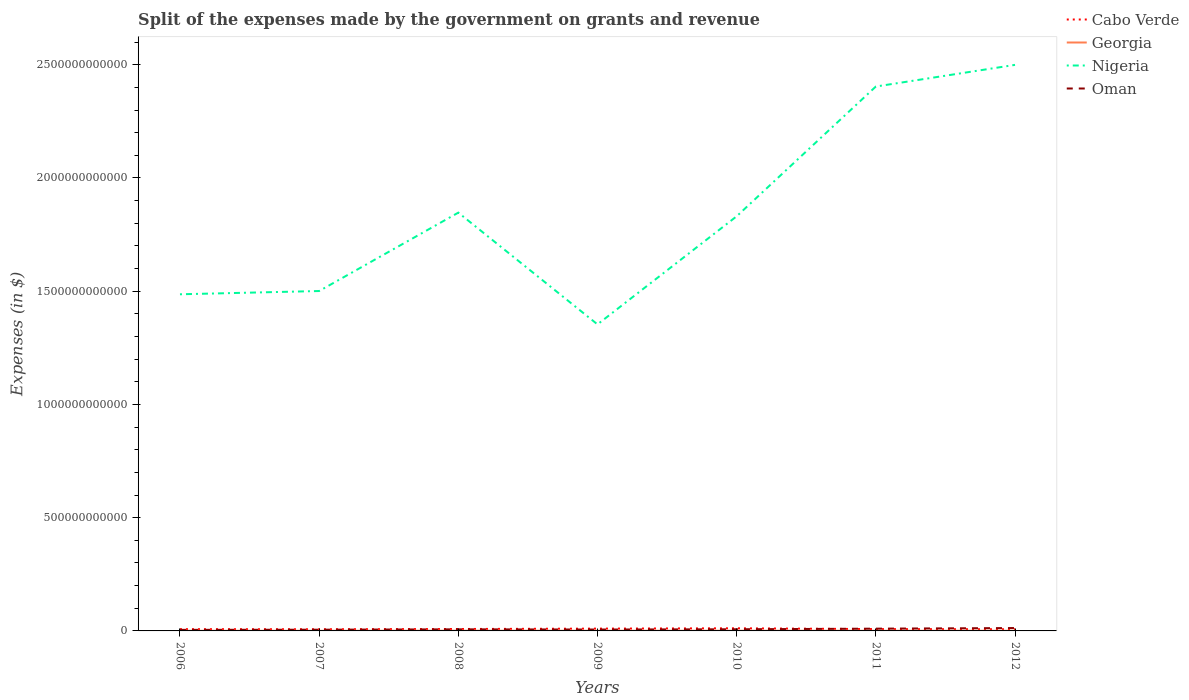Does the line corresponding to Cabo Verde intersect with the line corresponding to Oman?
Provide a short and direct response. Yes. Across all years, what is the maximum expenses made by the government on grants and revenue in Nigeria?
Your answer should be compact. 1.35e+12. In which year was the expenses made by the government on grants and revenue in Georgia maximum?
Your answer should be very brief. 2007. What is the total expenses made by the government on grants and revenue in Georgia in the graph?
Provide a succinct answer. -1.69e+08. What is the difference between the highest and the second highest expenses made by the government on grants and revenue in Nigeria?
Make the answer very short. 1.15e+12. Is the expenses made by the government on grants and revenue in Georgia strictly greater than the expenses made by the government on grants and revenue in Cabo Verde over the years?
Give a very brief answer. Yes. How many lines are there?
Provide a short and direct response. 4. What is the difference between two consecutive major ticks on the Y-axis?
Offer a very short reply. 5.00e+11. Does the graph contain any zero values?
Your answer should be very brief. No. How many legend labels are there?
Provide a short and direct response. 4. How are the legend labels stacked?
Ensure brevity in your answer.  Vertical. What is the title of the graph?
Your answer should be compact. Split of the expenses made by the government on grants and revenue. Does "Senegal" appear as one of the legend labels in the graph?
Your answer should be very brief. No. What is the label or title of the Y-axis?
Offer a terse response. Expenses (in $). What is the Expenses (in $) in Cabo Verde in 2006?
Provide a short and direct response. 7.76e+09. What is the Expenses (in $) in Georgia in 2006?
Make the answer very short. 6.60e+08. What is the Expenses (in $) in Nigeria in 2006?
Keep it short and to the point. 1.49e+12. What is the Expenses (in $) of Oman in 2006?
Your answer should be very brief. 4.63e+09. What is the Expenses (in $) in Cabo Verde in 2007?
Your answer should be very brief. 7.32e+09. What is the Expenses (in $) of Georgia in 2007?
Give a very brief answer. 5.61e+08. What is the Expenses (in $) in Nigeria in 2007?
Your response must be concise. 1.50e+12. What is the Expenses (in $) in Oman in 2007?
Give a very brief answer. 5.40e+09. What is the Expenses (in $) in Cabo Verde in 2008?
Your response must be concise. 8.47e+09. What is the Expenses (in $) in Georgia in 2008?
Ensure brevity in your answer.  9.76e+08. What is the Expenses (in $) of Nigeria in 2008?
Offer a terse response. 1.85e+12. What is the Expenses (in $) in Oman in 2008?
Give a very brief answer. 7.02e+09. What is the Expenses (in $) of Cabo Verde in 2009?
Keep it short and to the point. 1.02e+1. What is the Expenses (in $) of Georgia in 2009?
Give a very brief answer. 7.55e+08. What is the Expenses (in $) in Nigeria in 2009?
Your answer should be very brief. 1.35e+12. What is the Expenses (in $) in Oman in 2009?
Ensure brevity in your answer.  6.14e+09. What is the Expenses (in $) of Cabo Verde in 2010?
Make the answer very short. 1.16e+1. What is the Expenses (in $) of Georgia in 2010?
Your answer should be compact. 8.29e+08. What is the Expenses (in $) in Nigeria in 2010?
Keep it short and to the point. 1.83e+12. What is the Expenses (in $) of Oman in 2010?
Your answer should be compact. 7.31e+09. What is the Expenses (in $) in Cabo Verde in 2011?
Offer a terse response. 8.08e+09. What is the Expenses (in $) in Georgia in 2011?
Offer a terse response. 5.87e+08. What is the Expenses (in $) of Nigeria in 2011?
Your answer should be compact. 2.40e+12. What is the Expenses (in $) in Oman in 2011?
Your answer should be very brief. 9.99e+09. What is the Expenses (in $) in Cabo Verde in 2012?
Keep it short and to the point. 7.30e+09. What is the Expenses (in $) of Georgia in 2012?
Keep it short and to the point. 7.47e+08. What is the Expenses (in $) of Nigeria in 2012?
Offer a terse response. 2.50e+12. What is the Expenses (in $) in Oman in 2012?
Your answer should be compact. 1.27e+1. Across all years, what is the maximum Expenses (in $) of Cabo Verde?
Keep it short and to the point. 1.16e+1. Across all years, what is the maximum Expenses (in $) in Georgia?
Provide a succinct answer. 9.76e+08. Across all years, what is the maximum Expenses (in $) of Nigeria?
Offer a very short reply. 2.50e+12. Across all years, what is the maximum Expenses (in $) in Oman?
Give a very brief answer. 1.27e+1. Across all years, what is the minimum Expenses (in $) in Cabo Verde?
Keep it short and to the point. 7.30e+09. Across all years, what is the minimum Expenses (in $) in Georgia?
Your answer should be compact. 5.61e+08. Across all years, what is the minimum Expenses (in $) in Nigeria?
Provide a succinct answer. 1.35e+12. Across all years, what is the minimum Expenses (in $) of Oman?
Your answer should be compact. 4.63e+09. What is the total Expenses (in $) in Cabo Verde in the graph?
Give a very brief answer. 6.07e+1. What is the total Expenses (in $) in Georgia in the graph?
Provide a short and direct response. 5.12e+09. What is the total Expenses (in $) in Nigeria in the graph?
Give a very brief answer. 1.29e+13. What is the total Expenses (in $) in Oman in the graph?
Offer a terse response. 5.32e+1. What is the difference between the Expenses (in $) of Cabo Verde in 2006 and that in 2007?
Your response must be concise. 4.42e+08. What is the difference between the Expenses (in $) of Georgia in 2006 and that in 2007?
Your answer should be very brief. 9.92e+07. What is the difference between the Expenses (in $) in Nigeria in 2006 and that in 2007?
Give a very brief answer. -1.44e+1. What is the difference between the Expenses (in $) of Oman in 2006 and that in 2007?
Your answer should be compact. -7.66e+08. What is the difference between the Expenses (in $) of Cabo Verde in 2006 and that in 2008?
Make the answer very short. -7.10e+08. What is the difference between the Expenses (in $) of Georgia in 2006 and that in 2008?
Your response must be concise. -3.16e+08. What is the difference between the Expenses (in $) of Nigeria in 2006 and that in 2008?
Your answer should be compact. -3.60e+11. What is the difference between the Expenses (in $) in Oman in 2006 and that in 2008?
Provide a short and direct response. -2.38e+09. What is the difference between the Expenses (in $) of Cabo Verde in 2006 and that in 2009?
Offer a very short reply. -2.39e+09. What is the difference between the Expenses (in $) in Georgia in 2006 and that in 2009?
Offer a very short reply. -9.51e+07. What is the difference between the Expenses (in $) of Nigeria in 2006 and that in 2009?
Make the answer very short. 1.33e+11. What is the difference between the Expenses (in $) of Oman in 2006 and that in 2009?
Your answer should be very brief. -1.50e+09. What is the difference between the Expenses (in $) of Cabo Verde in 2006 and that in 2010?
Make the answer very short. -3.85e+09. What is the difference between the Expenses (in $) of Georgia in 2006 and that in 2010?
Keep it short and to the point. -1.69e+08. What is the difference between the Expenses (in $) in Nigeria in 2006 and that in 2010?
Offer a terse response. -3.44e+11. What is the difference between the Expenses (in $) of Oman in 2006 and that in 2010?
Your answer should be very brief. -2.67e+09. What is the difference between the Expenses (in $) of Cabo Verde in 2006 and that in 2011?
Keep it short and to the point. -3.14e+08. What is the difference between the Expenses (in $) of Georgia in 2006 and that in 2011?
Ensure brevity in your answer.  7.34e+07. What is the difference between the Expenses (in $) of Nigeria in 2006 and that in 2011?
Make the answer very short. -9.17e+11. What is the difference between the Expenses (in $) of Oman in 2006 and that in 2011?
Your answer should be very brief. -5.35e+09. What is the difference between the Expenses (in $) of Cabo Verde in 2006 and that in 2012?
Offer a terse response. 4.65e+08. What is the difference between the Expenses (in $) of Georgia in 2006 and that in 2012?
Ensure brevity in your answer.  -8.69e+07. What is the difference between the Expenses (in $) in Nigeria in 2006 and that in 2012?
Your response must be concise. -1.01e+12. What is the difference between the Expenses (in $) of Oman in 2006 and that in 2012?
Keep it short and to the point. -8.05e+09. What is the difference between the Expenses (in $) of Cabo Verde in 2007 and that in 2008?
Give a very brief answer. -1.15e+09. What is the difference between the Expenses (in $) in Georgia in 2007 and that in 2008?
Provide a succinct answer. -4.15e+08. What is the difference between the Expenses (in $) of Nigeria in 2007 and that in 2008?
Ensure brevity in your answer.  -3.46e+11. What is the difference between the Expenses (in $) of Oman in 2007 and that in 2008?
Offer a terse response. -1.62e+09. What is the difference between the Expenses (in $) in Cabo Verde in 2007 and that in 2009?
Keep it short and to the point. -2.83e+09. What is the difference between the Expenses (in $) in Georgia in 2007 and that in 2009?
Your answer should be very brief. -1.94e+08. What is the difference between the Expenses (in $) in Nigeria in 2007 and that in 2009?
Offer a very short reply. 1.47e+11. What is the difference between the Expenses (in $) of Oman in 2007 and that in 2009?
Your response must be concise. -7.37e+08. What is the difference between the Expenses (in $) in Cabo Verde in 2007 and that in 2010?
Offer a very short reply. -4.29e+09. What is the difference between the Expenses (in $) in Georgia in 2007 and that in 2010?
Your answer should be compact. -2.68e+08. What is the difference between the Expenses (in $) of Nigeria in 2007 and that in 2010?
Offer a terse response. -3.30e+11. What is the difference between the Expenses (in $) of Oman in 2007 and that in 2010?
Keep it short and to the point. -1.90e+09. What is the difference between the Expenses (in $) in Cabo Verde in 2007 and that in 2011?
Make the answer very short. -7.56e+08. What is the difference between the Expenses (in $) of Georgia in 2007 and that in 2011?
Your answer should be compact. -2.58e+07. What is the difference between the Expenses (in $) of Nigeria in 2007 and that in 2011?
Keep it short and to the point. -9.03e+11. What is the difference between the Expenses (in $) in Oman in 2007 and that in 2011?
Your response must be concise. -4.59e+09. What is the difference between the Expenses (in $) in Cabo Verde in 2007 and that in 2012?
Offer a terse response. 2.32e+07. What is the difference between the Expenses (in $) in Georgia in 2007 and that in 2012?
Your response must be concise. -1.86e+08. What is the difference between the Expenses (in $) in Nigeria in 2007 and that in 2012?
Provide a succinct answer. -9.99e+11. What is the difference between the Expenses (in $) of Oman in 2007 and that in 2012?
Ensure brevity in your answer.  -7.29e+09. What is the difference between the Expenses (in $) of Cabo Verde in 2008 and that in 2009?
Give a very brief answer. -1.68e+09. What is the difference between the Expenses (in $) of Georgia in 2008 and that in 2009?
Offer a terse response. 2.21e+08. What is the difference between the Expenses (in $) of Nigeria in 2008 and that in 2009?
Your response must be concise. 4.93e+11. What is the difference between the Expenses (in $) of Oman in 2008 and that in 2009?
Offer a terse response. 8.79e+08. What is the difference between the Expenses (in $) of Cabo Verde in 2008 and that in 2010?
Keep it short and to the point. -3.14e+09. What is the difference between the Expenses (in $) of Georgia in 2008 and that in 2010?
Ensure brevity in your answer.  1.47e+08. What is the difference between the Expenses (in $) of Nigeria in 2008 and that in 2010?
Provide a succinct answer. 1.61e+1. What is the difference between the Expenses (in $) in Oman in 2008 and that in 2010?
Give a very brief answer. -2.88e+08. What is the difference between the Expenses (in $) in Cabo Verde in 2008 and that in 2011?
Your answer should be very brief. 3.96e+08. What is the difference between the Expenses (in $) of Georgia in 2008 and that in 2011?
Offer a very short reply. 3.89e+08. What is the difference between the Expenses (in $) of Nigeria in 2008 and that in 2011?
Your answer should be very brief. -5.57e+11. What is the difference between the Expenses (in $) of Oman in 2008 and that in 2011?
Ensure brevity in your answer.  -2.97e+09. What is the difference between the Expenses (in $) in Cabo Verde in 2008 and that in 2012?
Your answer should be compact. 1.17e+09. What is the difference between the Expenses (in $) of Georgia in 2008 and that in 2012?
Give a very brief answer. 2.29e+08. What is the difference between the Expenses (in $) in Nigeria in 2008 and that in 2012?
Your answer should be very brief. -6.52e+11. What is the difference between the Expenses (in $) in Oman in 2008 and that in 2012?
Offer a very short reply. -5.67e+09. What is the difference between the Expenses (in $) in Cabo Verde in 2009 and that in 2010?
Offer a terse response. -1.45e+09. What is the difference between the Expenses (in $) of Georgia in 2009 and that in 2010?
Keep it short and to the point. -7.38e+07. What is the difference between the Expenses (in $) in Nigeria in 2009 and that in 2010?
Provide a succinct answer. -4.77e+11. What is the difference between the Expenses (in $) in Oman in 2009 and that in 2010?
Offer a very short reply. -1.17e+09. What is the difference between the Expenses (in $) in Cabo Verde in 2009 and that in 2011?
Give a very brief answer. 2.08e+09. What is the difference between the Expenses (in $) of Georgia in 2009 and that in 2011?
Provide a short and direct response. 1.68e+08. What is the difference between the Expenses (in $) of Nigeria in 2009 and that in 2011?
Provide a short and direct response. -1.05e+12. What is the difference between the Expenses (in $) in Oman in 2009 and that in 2011?
Give a very brief answer. -3.85e+09. What is the difference between the Expenses (in $) in Cabo Verde in 2009 and that in 2012?
Keep it short and to the point. 2.86e+09. What is the difference between the Expenses (in $) in Georgia in 2009 and that in 2012?
Offer a very short reply. 8.20e+06. What is the difference between the Expenses (in $) in Nigeria in 2009 and that in 2012?
Provide a succinct answer. -1.15e+12. What is the difference between the Expenses (in $) of Oman in 2009 and that in 2012?
Give a very brief answer. -6.55e+09. What is the difference between the Expenses (in $) in Cabo Verde in 2010 and that in 2011?
Keep it short and to the point. 3.53e+09. What is the difference between the Expenses (in $) of Georgia in 2010 and that in 2011?
Your response must be concise. 2.42e+08. What is the difference between the Expenses (in $) of Nigeria in 2010 and that in 2011?
Your answer should be very brief. -5.73e+11. What is the difference between the Expenses (in $) of Oman in 2010 and that in 2011?
Keep it short and to the point. -2.68e+09. What is the difference between the Expenses (in $) in Cabo Verde in 2010 and that in 2012?
Offer a very short reply. 4.31e+09. What is the difference between the Expenses (in $) in Georgia in 2010 and that in 2012?
Make the answer very short. 8.20e+07. What is the difference between the Expenses (in $) in Nigeria in 2010 and that in 2012?
Offer a terse response. -6.69e+11. What is the difference between the Expenses (in $) in Oman in 2010 and that in 2012?
Your response must be concise. -5.38e+09. What is the difference between the Expenses (in $) of Cabo Verde in 2011 and that in 2012?
Keep it short and to the point. 7.79e+08. What is the difference between the Expenses (in $) in Georgia in 2011 and that in 2012?
Your response must be concise. -1.60e+08. What is the difference between the Expenses (in $) in Nigeria in 2011 and that in 2012?
Your answer should be compact. -9.56e+1. What is the difference between the Expenses (in $) of Oman in 2011 and that in 2012?
Give a very brief answer. -2.70e+09. What is the difference between the Expenses (in $) of Cabo Verde in 2006 and the Expenses (in $) of Georgia in 2007?
Offer a terse response. 7.20e+09. What is the difference between the Expenses (in $) of Cabo Verde in 2006 and the Expenses (in $) of Nigeria in 2007?
Your response must be concise. -1.49e+12. What is the difference between the Expenses (in $) of Cabo Verde in 2006 and the Expenses (in $) of Oman in 2007?
Provide a short and direct response. 2.36e+09. What is the difference between the Expenses (in $) of Georgia in 2006 and the Expenses (in $) of Nigeria in 2007?
Your response must be concise. -1.50e+12. What is the difference between the Expenses (in $) of Georgia in 2006 and the Expenses (in $) of Oman in 2007?
Your answer should be compact. -4.74e+09. What is the difference between the Expenses (in $) in Nigeria in 2006 and the Expenses (in $) in Oman in 2007?
Keep it short and to the point. 1.48e+12. What is the difference between the Expenses (in $) of Cabo Verde in 2006 and the Expenses (in $) of Georgia in 2008?
Give a very brief answer. 6.79e+09. What is the difference between the Expenses (in $) of Cabo Verde in 2006 and the Expenses (in $) of Nigeria in 2008?
Provide a succinct answer. -1.84e+12. What is the difference between the Expenses (in $) of Cabo Verde in 2006 and the Expenses (in $) of Oman in 2008?
Your answer should be compact. 7.44e+08. What is the difference between the Expenses (in $) in Georgia in 2006 and the Expenses (in $) in Nigeria in 2008?
Your answer should be very brief. -1.85e+12. What is the difference between the Expenses (in $) in Georgia in 2006 and the Expenses (in $) in Oman in 2008?
Your answer should be compact. -6.36e+09. What is the difference between the Expenses (in $) in Nigeria in 2006 and the Expenses (in $) in Oman in 2008?
Offer a terse response. 1.48e+12. What is the difference between the Expenses (in $) of Cabo Verde in 2006 and the Expenses (in $) of Georgia in 2009?
Your response must be concise. 7.01e+09. What is the difference between the Expenses (in $) in Cabo Verde in 2006 and the Expenses (in $) in Nigeria in 2009?
Provide a succinct answer. -1.35e+12. What is the difference between the Expenses (in $) in Cabo Verde in 2006 and the Expenses (in $) in Oman in 2009?
Provide a short and direct response. 1.62e+09. What is the difference between the Expenses (in $) in Georgia in 2006 and the Expenses (in $) in Nigeria in 2009?
Provide a short and direct response. -1.35e+12. What is the difference between the Expenses (in $) of Georgia in 2006 and the Expenses (in $) of Oman in 2009?
Make the answer very short. -5.48e+09. What is the difference between the Expenses (in $) in Nigeria in 2006 and the Expenses (in $) in Oman in 2009?
Your response must be concise. 1.48e+12. What is the difference between the Expenses (in $) of Cabo Verde in 2006 and the Expenses (in $) of Georgia in 2010?
Provide a short and direct response. 6.93e+09. What is the difference between the Expenses (in $) of Cabo Verde in 2006 and the Expenses (in $) of Nigeria in 2010?
Your answer should be very brief. -1.82e+12. What is the difference between the Expenses (in $) of Cabo Verde in 2006 and the Expenses (in $) of Oman in 2010?
Give a very brief answer. 4.57e+08. What is the difference between the Expenses (in $) of Georgia in 2006 and the Expenses (in $) of Nigeria in 2010?
Provide a short and direct response. -1.83e+12. What is the difference between the Expenses (in $) in Georgia in 2006 and the Expenses (in $) in Oman in 2010?
Offer a terse response. -6.64e+09. What is the difference between the Expenses (in $) of Nigeria in 2006 and the Expenses (in $) of Oman in 2010?
Give a very brief answer. 1.48e+12. What is the difference between the Expenses (in $) of Cabo Verde in 2006 and the Expenses (in $) of Georgia in 2011?
Keep it short and to the point. 7.18e+09. What is the difference between the Expenses (in $) of Cabo Verde in 2006 and the Expenses (in $) of Nigeria in 2011?
Provide a succinct answer. -2.40e+12. What is the difference between the Expenses (in $) of Cabo Verde in 2006 and the Expenses (in $) of Oman in 2011?
Your response must be concise. -2.23e+09. What is the difference between the Expenses (in $) of Georgia in 2006 and the Expenses (in $) of Nigeria in 2011?
Keep it short and to the point. -2.40e+12. What is the difference between the Expenses (in $) of Georgia in 2006 and the Expenses (in $) of Oman in 2011?
Provide a short and direct response. -9.33e+09. What is the difference between the Expenses (in $) in Nigeria in 2006 and the Expenses (in $) in Oman in 2011?
Give a very brief answer. 1.48e+12. What is the difference between the Expenses (in $) of Cabo Verde in 2006 and the Expenses (in $) of Georgia in 2012?
Your answer should be very brief. 7.02e+09. What is the difference between the Expenses (in $) of Cabo Verde in 2006 and the Expenses (in $) of Nigeria in 2012?
Offer a very short reply. -2.49e+12. What is the difference between the Expenses (in $) of Cabo Verde in 2006 and the Expenses (in $) of Oman in 2012?
Provide a succinct answer. -4.93e+09. What is the difference between the Expenses (in $) in Georgia in 2006 and the Expenses (in $) in Nigeria in 2012?
Make the answer very short. -2.50e+12. What is the difference between the Expenses (in $) of Georgia in 2006 and the Expenses (in $) of Oman in 2012?
Keep it short and to the point. -1.20e+1. What is the difference between the Expenses (in $) in Nigeria in 2006 and the Expenses (in $) in Oman in 2012?
Your answer should be very brief. 1.47e+12. What is the difference between the Expenses (in $) in Cabo Verde in 2007 and the Expenses (in $) in Georgia in 2008?
Make the answer very short. 6.34e+09. What is the difference between the Expenses (in $) of Cabo Verde in 2007 and the Expenses (in $) of Nigeria in 2008?
Your response must be concise. -1.84e+12. What is the difference between the Expenses (in $) in Cabo Verde in 2007 and the Expenses (in $) in Oman in 2008?
Keep it short and to the point. 3.03e+08. What is the difference between the Expenses (in $) in Georgia in 2007 and the Expenses (in $) in Nigeria in 2008?
Offer a very short reply. -1.85e+12. What is the difference between the Expenses (in $) in Georgia in 2007 and the Expenses (in $) in Oman in 2008?
Offer a very short reply. -6.46e+09. What is the difference between the Expenses (in $) in Nigeria in 2007 and the Expenses (in $) in Oman in 2008?
Your response must be concise. 1.49e+12. What is the difference between the Expenses (in $) in Cabo Verde in 2007 and the Expenses (in $) in Georgia in 2009?
Give a very brief answer. 6.57e+09. What is the difference between the Expenses (in $) of Cabo Verde in 2007 and the Expenses (in $) of Nigeria in 2009?
Ensure brevity in your answer.  -1.35e+12. What is the difference between the Expenses (in $) in Cabo Verde in 2007 and the Expenses (in $) in Oman in 2009?
Ensure brevity in your answer.  1.18e+09. What is the difference between the Expenses (in $) in Georgia in 2007 and the Expenses (in $) in Nigeria in 2009?
Make the answer very short. -1.35e+12. What is the difference between the Expenses (in $) of Georgia in 2007 and the Expenses (in $) of Oman in 2009?
Your answer should be very brief. -5.58e+09. What is the difference between the Expenses (in $) in Nigeria in 2007 and the Expenses (in $) in Oman in 2009?
Your response must be concise. 1.49e+12. What is the difference between the Expenses (in $) of Cabo Verde in 2007 and the Expenses (in $) of Georgia in 2010?
Your answer should be very brief. 6.49e+09. What is the difference between the Expenses (in $) in Cabo Verde in 2007 and the Expenses (in $) in Nigeria in 2010?
Offer a very short reply. -1.82e+12. What is the difference between the Expenses (in $) of Cabo Verde in 2007 and the Expenses (in $) of Oman in 2010?
Your response must be concise. 1.51e+07. What is the difference between the Expenses (in $) in Georgia in 2007 and the Expenses (in $) in Nigeria in 2010?
Offer a terse response. -1.83e+12. What is the difference between the Expenses (in $) in Georgia in 2007 and the Expenses (in $) in Oman in 2010?
Your answer should be compact. -6.74e+09. What is the difference between the Expenses (in $) of Nigeria in 2007 and the Expenses (in $) of Oman in 2010?
Your response must be concise. 1.49e+12. What is the difference between the Expenses (in $) of Cabo Verde in 2007 and the Expenses (in $) of Georgia in 2011?
Keep it short and to the point. 6.73e+09. What is the difference between the Expenses (in $) in Cabo Verde in 2007 and the Expenses (in $) in Nigeria in 2011?
Provide a short and direct response. -2.40e+12. What is the difference between the Expenses (in $) in Cabo Verde in 2007 and the Expenses (in $) in Oman in 2011?
Keep it short and to the point. -2.67e+09. What is the difference between the Expenses (in $) in Georgia in 2007 and the Expenses (in $) in Nigeria in 2011?
Your answer should be very brief. -2.40e+12. What is the difference between the Expenses (in $) in Georgia in 2007 and the Expenses (in $) in Oman in 2011?
Offer a very short reply. -9.43e+09. What is the difference between the Expenses (in $) of Nigeria in 2007 and the Expenses (in $) of Oman in 2011?
Your response must be concise. 1.49e+12. What is the difference between the Expenses (in $) in Cabo Verde in 2007 and the Expenses (in $) in Georgia in 2012?
Keep it short and to the point. 6.57e+09. What is the difference between the Expenses (in $) of Cabo Verde in 2007 and the Expenses (in $) of Nigeria in 2012?
Your response must be concise. -2.49e+12. What is the difference between the Expenses (in $) in Cabo Verde in 2007 and the Expenses (in $) in Oman in 2012?
Your response must be concise. -5.37e+09. What is the difference between the Expenses (in $) of Georgia in 2007 and the Expenses (in $) of Nigeria in 2012?
Your answer should be compact. -2.50e+12. What is the difference between the Expenses (in $) of Georgia in 2007 and the Expenses (in $) of Oman in 2012?
Provide a succinct answer. -1.21e+1. What is the difference between the Expenses (in $) of Nigeria in 2007 and the Expenses (in $) of Oman in 2012?
Offer a terse response. 1.49e+12. What is the difference between the Expenses (in $) of Cabo Verde in 2008 and the Expenses (in $) of Georgia in 2009?
Keep it short and to the point. 7.72e+09. What is the difference between the Expenses (in $) of Cabo Verde in 2008 and the Expenses (in $) of Nigeria in 2009?
Keep it short and to the point. -1.35e+12. What is the difference between the Expenses (in $) of Cabo Verde in 2008 and the Expenses (in $) of Oman in 2009?
Your response must be concise. 2.33e+09. What is the difference between the Expenses (in $) of Georgia in 2008 and the Expenses (in $) of Nigeria in 2009?
Give a very brief answer. -1.35e+12. What is the difference between the Expenses (in $) of Georgia in 2008 and the Expenses (in $) of Oman in 2009?
Offer a very short reply. -5.16e+09. What is the difference between the Expenses (in $) in Nigeria in 2008 and the Expenses (in $) in Oman in 2009?
Offer a very short reply. 1.84e+12. What is the difference between the Expenses (in $) of Cabo Verde in 2008 and the Expenses (in $) of Georgia in 2010?
Give a very brief answer. 7.64e+09. What is the difference between the Expenses (in $) of Cabo Verde in 2008 and the Expenses (in $) of Nigeria in 2010?
Offer a very short reply. -1.82e+12. What is the difference between the Expenses (in $) of Cabo Verde in 2008 and the Expenses (in $) of Oman in 2010?
Keep it short and to the point. 1.17e+09. What is the difference between the Expenses (in $) in Georgia in 2008 and the Expenses (in $) in Nigeria in 2010?
Provide a succinct answer. -1.83e+12. What is the difference between the Expenses (in $) of Georgia in 2008 and the Expenses (in $) of Oman in 2010?
Your answer should be compact. -6.33e+09. What is the difference between the Expenses (in $) in Nigeria in 2008 and the Expenses (in $) in Oman in 2010?
Your answer should be very brief. 1.84e+12. What is the difference between the Expenses (in $) in Cabo Verde in 2008 and the Expenses (in $) in Georgia in 2011?
Provide a succinct answer. 7.88e+09. What is the difference between the Expenses (in $) of Cabo Verde in 2008 and the Expenses (in $) of Nigeria in 2011?
Give a very brief answer. -2.40e+12. What is the difference between the Expenses (in $) of Cabo Verde in 2008 and the Expenses (in $) of Oman in 2011?
Keep it short and to the point. -1.52e+09. What is the difference between the Expenses (in $) of Georgia in 2008 and the Expenses (in $) of Nigeria in 2011?
Offer a very short reply. -2.40e+12. What is the difference between the Expenses (in $) in Georgia in 2008 and the Expenses (in $) in Oman in 2011?
Your response must be concise. -9.01e+09. What is the difference between the Expenses (in $) of Nigeria in 2008 and the Expenses (in $) of Oman in 2011?
Offer a very short reply. 1.84e+12. What is the difference between the Expenses (in $) in Cabo Verde in 2008 and the Expenses (in $) in Georgia in 2012?
Offer a very short reply. 7.72e+09. What is the difference between the Expenses (in $) in Cabo Verde in 2008 and the Expenses (in $) in Nigeria in 2012?
Provide a short and direct response. -2.49e+12. What is the difference between the Expenses (in $) in Cabo Verde in 2008 and the Expenses (in $) in Oman in 2012?
Offer a very short reply. -4.22e+09. What is the difference between the Expenses (in $) of Georgia in 2008 and the Expenses (in $) of Nigeria in 2012?
Provide a short and direct response. -2.50e+12. What is the difference between the Expenses (in $) in Georgia in 2008 and the Expenses (in $) in Oman in 2012?
Your response must be concise. -1.17e+1. What is the difference between the Expenses (in $) in Nigeria in 2008 and the Expenses (in $) in Oman in 2012?
Your response must be concise. 1.83e+12. What is the difference between the Expenses (in $) in Cabo Verde in 2009 and the Expenses (in $) in Georgia in 2010?
Provide a short and direct response. 9.33e+09. What is the difference between the Expenses (in $) of Cabo Verde in 2009 and the Expenses (in $) of Nigeria in 2010?
Provide a succinct answer. -1.82e+12. What is the difference between the Expenses (in $) of Cabo Verde in 2009 and the Expenses (in $) of Oman in 2010?
Offer a very short reply. 2.85e+09. What is the difference between the Expenses (in $) of Georgia in 2009 and the Expenses (in $) of Nigeria in 2010?
Offer a terse response. -1.83e+12. What is the difference between the Expenses (in $) in Georgia in 2009 and the Expenses (in $) in Oman in 2010?
Keep it short and to the point. -6.55e+09. What is the difference between the Expenses (in $) in Nigeria in 2009 and the Expenses (in $) in Oman in 2010?
Your response must be concise. 1.35e+12. What is the difference between the Expenses (in $) in Cabo Verde in 2009 and the Expenses (in $) in Georgia in 2011?
Your answer should be very brief. 9.57e+09. What is the difference between the Expenses (in $) of Cabo Verde in 2009 and the Expenses (in $) of Nigeria in 2011?
Offer a very short reply. -2.39e+12. What is the difference between the Expenses (in $) of Cabo Verde in 2009 and the Expenses (in $) of Oman in 2011?
Make the answer very short. 1.66e+08. What is the difference between the Expenses (in $) in Georgia in 2009 and the Expenses (in $) in Nigeria in 2011?
Provide a succinct answer. -2.40e+12. What is the difference between the Expenses (in $) in Georgia in 2009 and the Expenses (in $) in Oman in 2011?
Provide a succinct answer. -9.23e+09. What is the difference between the Expenses (in $) in Nigeria in 2009 and the Expenses (in $) in Oman in 2011?
Provide a succinct answer. 1.34e+12. What is the difference between the Expenses (in $) of Cabo Verde in 2009 and the Expenses (in $) of Georgia in 2012?
Make the answer very short. 9.41e+09. What is the difference between the Expenses (in $) of Cabo Verde in 2009 and the Expenses (in $) of Nigeria in 2012?
Your response must be concise. -2.49e+12. What is the difference between the Expenses (in $) in Cabo Verde in 2009 and the Expenses (in $) in Oman in 2012?
Make the answer very short. -2.53e+09. What is the difference between the Expenses (in $) of Georgia in 2009 and the Expenses (in $) of Nigeria in 2012?
Make the answer very short. -2.50e+12. What is the difference between the Expenses (in $) in Georgia in 2009 and the Expenses (in $) in Oman in 2012?
Provide a succinct answer. -1.19e+1. What is the difference between the Expenses (in $) of Nigeria in 2009 and the Expenses (in $) of Oman in 2012?
Make the answer very short. 1.34e+12. What is the difference between the Expenses (in $) in Cabo Verde in 2010 and the Expenses (in $) in Georgia in 2011?
Offer a very short reply. 1.10e+1. What is the difference between the Expenses (in $) of Cabo Verde in 2010 and the Expenses (in $) of Nigeria in 2011?
Your answer should be compact. -2.39e+12. What is the difference between the Expenses (in $) in Cabo Verde in 2010 and the Expenses (in $) in Oman in 2011?
Offer a terse response. 1.62e+09. What is the difference between the Expenses (in $) of Georgia in 2010 and the Expenses (in $) of Nigeria in 2011?
Give a very brief answer. -2.40e+12. What is the difference between the Expenses (in $) in Georgia in 2010 and the Expenses (in $) in Oman in 2011?
Provide a succinct answer. -9.16e+09. What is the difference between the Expenses (in $) of Nigeria in 2010 and the Expenses (in $) of Oman in 2011?
Your answer should be compact. 1.82e+12. What is the difference between the Expenses (in $) of Cabo Verde in 2010 and the Expenses (in $) of Georgia in 2012?
Provide a short and direct response. 1.09e+1. What is the difference between the Expenses (in $) in Cabo Verde in 2010 and the Expenses (in $) in Nigeria in 2012?
Ensure brevity in your answer.  -2.49e+12. What is the difference between the Expenses (in $) of Cabo Verde in 2010 and the Expenses (in $) of Oman in 2012?
Make the answer very short. -1.08e+09. What is the difference between the Expenses (in $) in Georgia in 2010 and the Expenses (in $) in Nigeria in 2012?
Give a very brief answer. -2.50e+12. What is the difference between the Expenses (in $) in Georgia in 2010 and the Expenses (in $) in Oman in 2012?
Provide a succinct answer. -1.19e+1. What is the difference between the Expenses (in $) of Nigeria in 2010 and the Expenses (in $) of Oman in 2012?
Offer a very short reply. 1.82e+12. What is the difference between the Expenses (in $) of Cabo Verde in 2011 and the Expenses (in $) of Georgia in 2012?
Provide a succinct answer. 7.33e+09. What is the difference between the Expenses (in $) in Cabo Verde in 2011 and the Expenses (in $) in Nigeria in 2012?
Your answer should be very brief. -2.49e+12. What is the difference between the Expenses (in $) of Cabo Verde in 2011 and the Expenses (in $) of Oman in 2012?
Ensure brevity in your answer.  -4.61e+09. What is the difference between the Expenses (in $) of Georgia in 2011 and the Expenses (in $) of Nigeria in 2012?
Your response must be concise. -2.50e+12. What is the difference between the Expenses (in $) of Georgia in 2011 and the Expenses (in $) of Oman in 2012?
Offer a terse response. -1.21e+1. What is the difference between the Expenses (in $) of Nigeria in 2011 and the Expenses (in $) of Oman in 2012?
Your answer should be compact. 2.39e+12. What is the average Expenses (in $) of Cabo Verde per year?
Keep it short and to the point. 8.67e+09. What is the average Expenses (in $) in Georgia per year?
Provide a succinct answer. 7.31e+08. What is the average Expenses (in $) of Nigeria per year?
Provide a short and direct response. 1.85e+12. What is the average Expenses (in $) of Oman per year?
Give a very brief answer. 7.60e+09. In the year 2006, what is the difference between the Expenses (in $) of Cabo Verde and Expenses (in $) of Georgia?
Offer a very short reply. 7.10e+09. In the year 2006, what is the difference between the Expenses (in $) in Cabo Verde and Expenses (in $) in Nigeria?
Give a very brief answer. -1.48e+12. In the year 2006, what is the difference between the Expenses (in $) in Cabo Verde and Expenses (in $) in Oman?
Ensure brevity in your answer.  3.13e+09. In the year 2006, what is the difference between the Expenses (in $) of Georgia and Expenses (in $) of Nigeria?
Your answer should be very brief. -1.49e+12. In the year 2006, what is the difference between the Expenses (in $) of Georgia and Expenses (in $) of Oman?
Give a very brief answer. -3.97e+09. In the year 2006, what is the difference between the Expenses (in $) of Nigeria and Expenses (in $) of Oman?
Provide a succinct answer. 1.48e+12. In the year 2007, what is the difference between the Expenses (in $) of Cabo Verde and Expenses (in $) of Georgia?
Offer a very short reply. 6.76e+09. In the year 2007, what is the difference between the Expenses (in $) in Cabo Verde and Expenses (in $) in Nigeria?
Ensure brevity in your answer.  -1.49e+12. In the year 2007, what is the difference between the Expenses (in $) of Cabo Verde and Expenses (in $) of Oman?
Make the answer very short. 1.92e+09. In the year 2007, what is the difference between the Expenses (in $) in Georgia and Expenses (in $) in Nigeria?
Keep it short and to the point. -1.50e+12. In the year 2007, what is the difference between the Expenses (in $) in Georgia and Expenses (in $) in Oman?
Your response must be concise. -4.84e+09. In the year 2007, what is the difference between the Expenses (in $) in Nigeria and Expenses (in $) in Oman?
Your answer should be compact. 1.50e+12. In the year 2008, what is the difference between the Expenses (in $) of Cabo Verde and Expenses (in $) of Georgia?
Offer a very short reply. 7.50e+09. In the year 2008, what is the difference between the Expenses (in $) of Cabo Verde and Expenses (in $) of Nigeria?
Your response must be concise. -1.84e+12. In the year 2008, what is the difference between the Expenses (in $) of Cabo Verde and Expenses (in $) of Oman?
Provide a short and direct response. 1.45e+09. In the year 2008, what is the difference between the Expenses (in $) in Georgia and Expenses (in $) in Nigeria?
Your answer should be very brief. -1.85e+12. In the year 2008, what is the difference between the Expenses (in $) of Georgia and Expenses (in $) of Oman?
Your response must be concise. -6.04e+09. In the year 2008, what is the difference between the Expenses (in $) of Nigeria and Expenses (in $) of Oman?
Ensure brevity in your answer.  1.84e+12. In the year 2009, what is the difference between the Expenses (in $) in Cabo Verde and Expenses (in $) in Georgia?
Your response must be concise. 9.40e+09. In the year 2009, what is the difference between the Expenses (in $) of Cabo Verde and Expenses (in $) of Nigeria?
Your answer should be very brief. -1.34e+12. In the year 2009, what is the difference between the Expenses (in $) in Cabo Verde and Expenses (in $) in Oman?
Ensure brevity in your answer.  4.02e+09. In the year 2009, what is the difference between the Expenses (in $) in Georgia and Expenses (in $) in Nigeria?
Offer a terse response. -1.35e+12. In the year 2009, what is the difference between the Expenses (in $) of Georgia and Expenses (in $) of Oman?
Provide a short and direct response. -5.38e+09. In the year 2009, what is the difference between the Expenses (in $) of Nigeria and Expenses (in $) of Oman?
Offer a terse response. 1.35e+12. In the year 2010, what is the difference between the Expenses (in $) in Cabo Verde and Expenses (in $) in Georgia?
Offer a very short reply. 1.08e+1. In the year 2010, what is the difference between the Expenses (in $) in Cabo Verde and Expenses (in $) in Nigeria?
Ensure brevity in your answer.  -1.82e+12. In the year 2010, what is the difference between the Expenses (in $) in Cabo Verde and Expenses (in $) in Oman?
Provide a short and direct response. 4.30e+09. In the year 2010, what is the difference between the Expenses (in $) in Georgia and Expenses (in $) in Nigeria?
Make the answer very short. -1.83e+12. In the year 2010, what is the difference between the Expenses (in $) of Georgia and Expenses (in $) of Oman?
Provide a short and direct response. -6.48e+09. In the year 2010, what is the difference between the Expenses (in $) in Nigeria and Expenses (in $) in Oman?
Your response must be concise. 1.82e+12. In the year 2011, what is the difference between the Expenses (in $) of Cabo Verde and Expenses (in $) of Georgia?
Your answer should be very brief. 7.49e+09. In the year 2011, what is the difference between the Expenses (in $) of Cabo Verde and Expenses (in $) of Nigeria?
Give a very brief answer. -2.40e+12. In the year 2011, what is the difference between the Expenses (in $) of Cabo Verde and Expenses (in $) of Oman?
Your answer should be very brief. -1.91e+09. In the year 2011, what is the difference between the Expenses (in $) of Georgia and Expenses (in $) of Nigeria?
Provide a succinct answer. -2.40e+12. In the year 2011, what is the difference between the Expenses (in $) of Georgia and Expenses (in $) of Oman?
Give a very brief answer. -9.40e+09. In the year 2011, what is the difference between the Expenses (in $) of Nigeria and Expenses (in $) of Oman?
Your answer should be very brief. 2.39e+12. In the year 2012, what is the difference between the Expenses (in $) in Cabo Verde and Expenses (in $) in Georgia?
Make the answer very short. 6.55e+09. In the year 2012, what is the difference between the Expenses (in $) of Cabo Verde and Expenses (in $) of Nigeria?
Make the answer very short. -2.49e+12. In the year 2012, what is the difference between the Expenses (in $) of Cabo Verde and Expenses (in $) of Oman?
Provide a succinct answer. -5.39e+09. In the year 2012, what is the difference between the Expenses (in $) of Georgia and Expenses (in $) of Nigeria?
Your answer should be compact. -2.50e+12. In the year 2012, what is the difference between the Expenses (in $) of Georgia and Expenses (in $) of Oman?
Your answer should be compact. -1.19e+1. In the year 2012, what is the difference between the Expenses (in $) of Nigeria and Expenses (in $) of Oman?
Provide a short and direct response. 2.49e+12. What is the ratio of the Expenses (in $) of Cabo Verde in 2006 to that in 2007?
Provide a succinct answer. 1.06. What is the ratio of the Expenses (in $) in Georgia in 2006 to that in 2007?
Give a very brief answer. 1.18. What is the ratio of the Expenses (in $) in Oman in 2006 to that in 2007?
Your answer should be very brief. 0.86. What is the ratio of the Expenses (in $) in Cabo Verde in 2006 to that in 2008?
Offer a very short reply. 0.92. What is the ratio of the Expenses (in $) in Georgia in 2006 to that in 2008?
Keep it short and to the point. 0.68. What is the ratio of the Expenses (in $) of Nigeria in 2006 to that in 2008?
Make the answer very short. 0.8. What is the ratio of the Expenses (in $) of Oman in 2006 to that in 2008?
Offer a terse response. 0.66. What is the ratio of the Expenses (in $) of Cabo Verde in 2006 to that in 2009?
Offer a terse response. 0.76. What is the ratio of the Expenses (in $) in Georgia in 2006 to that in 2009?
Offer a very short reply. 0.87. What is the ratio of the Expenses (in $) of Nigeria in 2006 to that in 2009?
Provide a succinct answer. 1.1. What is the ratio of the Expenses (in $) in Oman in 2006 to that in 2009?
Ensure brevity in your answer.  0.76. What is the ratio of the Expenses (in $) in Cabo Verde in 2006 to that in 2010?
Your answer should be compact. 0.67. What is the ratio of the Expenses (in $) of Georgia in 2006 to that in 2010?
Give a very brief answer. 0.8. What is the ratio of the Expenses (in $) in Nigeria in 2006 to that in 2010?
Ensure brevity in your answer.  0.81. What is the ratio of the Expenses (in $) of Oman in 2006 to that in 2010?
Ensure brevity in your answer.  0.63. What is the ratio of the Expenses (in $) of Cabo Verde in 2006 to that in 2011?
Keep it short and to the point. 0.96. What is the ratio of the Expenses (in $) of Georgia in 2006 to that in 2011?
Keep it short and to the point. 1.13. What is the ratio of the Expenses (in $) in Nigeria in 2006 to that in 2011?
Give a very brief answer. 0.62. What is the ratio of the Expenses (in $) of Oman in 2006 to that in 2011?
Make the answer very short. 0.46. What is the ratio of the Expenses (in $) of Cabo Verde in 2006 to that in 2012?
Your answer should be compact. 1.06. What is the ratio of the Expenses (in $) of Georgia in 2006 to that in 2012?
Your answer should be very brief. 0.88. What is the ratio of the Expenses (in $) of Nigeria in 2006 to that in 2012?
Make the answer very short. 0.59. What is the ratio of the Expenses (in $) in Oman in 2006 to that in 2012?
Your response must be concise. 0.37. What is the ratio of the Expenses (in $) in Cabo Verde in 2007 to that in 2008?
Offer a very short reply. 0.86. What is the ratio of the Expenses (in $) of Georgia in 2007 to that in 2008?
Give a very brief answer. 0.57. What is the ratio of the Expenses (in $) of Nigeria in 2007 to that in 2008?
Make the answer very short. 0.81. What is the ratio of the Expenses (in $) in Oman in 2007 to that in 2008?
Offer a very short reply. 0.77. What is the ratio of the Expenses (in $) of Cabo Verde in 2007 to that in 2009?
Offer a terse response. 0.72. What is the ratio of the Expenses (in $) of Georgia in 2007 to that in 2009?
Offer a terse response. 0.74. What is the ratio of the Expenses (in $) of Nigeria in 2007 to that in 2009?
Offer a very short reply. 1.11. What is the ratio of the Expenses (in $) of Oman in 2007 to that in 2009?
Provide a succinct answer. 0.88. What is the ratio of the Expenses (in $) in Cabo Verde in 2007 to that in 2010?
Your answer should be compact. 0.63. What is the ratio of the Expenses (in $) of Georgia in 2007 to that in 2010?
Your answer should be compact. 0.68. What is the ratio of the Expenses (in $) in Nigeria in 2007 to that in 2010?
Give a very brief answer. 0.82. What is the ratio of the Expenses (in $) of Oman in 2007 to that in 2010?
Provide a succinct answer. 0.74. What is the ratio of the Expenses (in $) of Cabo Verde in 2007 to that in 2011?
Offer a very short reply. 0.91. What is the ratio of the Expenses (in $) in Georgia in 2007 to that in 2011?
Make the answer very short. 0.96. What is the ratio of the Expenses (in $) in Nigeria in 2007 to that in 2011?
Offer a very short reply. 0.62. What is the ratio of the Expenses (in $) in Oman in 2007 to that in 2011?
Provide a short and direct response. 0.54. What is the ratio of the Expenses (in $) in Georgia in 2007 to that in 2012?
Your answer should be very brief. 0.75. What is the ratio of the Expenses (in $) of Nigeria in 2007 to that in 2012?
Your response must be concise. 0.6. What is the ratio of the Expenses (in $) in Oman in 2007 to that in 2012?
Provide a succinct answer. 0.43. What is the ratio of the Expenses (in $) in Cabo Verde in 2008 to that in 2009?
Provide a succinct answer. 0.83. What is the ratio of the Expenses (in $) in Georgia in 2008 to that in 2009?
Provide a short and direct response. 1.29. What is the ratio of the Expenses (in $) of Nigeria in 2008 to that in 2009?
Provide a succinct answer. 1.36. What is the ratio of the Expenses (in $) in Oman in 2008 to that in 2009?
Offer a terse response. 1.14. What is the ratio of the Expenses (in $) in Cabo Verde in 2008 to that in 2010?
Offer a very short reply. 0.73. What is the ratio of the Expenses (in $) of Georgia in 2008 to that in 2010?
Give a very brief answer. 1.18. What is the ratio of the Expenses (in $) of Nigeria in 2008 to that in 2010?
Provide a short and direct response. 1.01. What is the ratio of the Expenses (in $) of Oman in 2008 to that in 2010?
Make the answer very short. 0.96. What is the ratio of the Expenses (in $) in Cabo Verde in 2008 to that in 2011?
Offer a very short reply. 1.05. What is the ratio of the Expenses (in $) in Georgia in 2008 to that in 2011?
Keep it short and to the point. 1.66. What is the ratio of the Expenses (in $) of Nigeria in 2008 to that in 2011?
Offer a terse response. 0.77. What is the ratio of the Expenses (in $) in Oman in 2008 to that in 2011?
Offer a terse response. 0.7. What is the ratio of the Expenses (in $) of Cabo Verde in 2008 to that in 2012?
Your answer should be compact. 1.16. What is the ratio of the Expenses (in $) of Georgia in 2008 to that in 2012?
Keep it short and to the point. 1.31. What is the ratio of the Expenses (in $) in Nigeria in 2008 to that in 2012?
Provide a short and direct response. 0.74. What is the ratio of the Expenses (in $) of Oman in 2008 to that in 2012?
Your answer should be very brief. 0.55. What is the ratio of the Expenses (in $) of Cabo Verde in 2009 to that in 2010?
Offer a very short reply. 0.87. What is the ratio of the Expenses (in $) in Georgia in 2009 to that in 2010?
Provide a short and direct response. 0.91. What is the ratio of the Expenses (in $) in Nigeria in 2009 to that in 2010?
Your response must be concise. 0.74. What is the ratio of the Expenses (in $) of Oman in 2009 to that in 2010?
Offer a terse response. 0.84. What is the ratio of the Expenses (in $) in Cabo Verde in 2009 to that in 2011?
Provide a succinct answer. 1.26. What is the ratio of the Expenses (in $) of Georgia in 2009 to that in 2011?
Ensure brevity in your answer.  1.29. What is the ratio of the Expenses (in $) in Nigeria in 2009 to that in 2011?
Ensure brevity in your answer.  0.56. What is the ratio of the Expenses (in $) of Oman in 2009 to that in 2011?
Your answer should be very brief. 0.61. What is the ratio of the Expenses (in $) of Cabo Verde in 2009 to that in 2012?
Keep it short and to the point. 1.39. What is the ratio of the Expenses (in $) of Nigeria in 2009 to that in 2012?
Provide a short and direct response. 0.54. What is the ratio of the Expenses (in $) in Oman in 2009 to that in 2012?
Provide a short and direct response. 0.48. What is the ratio of the Expenses (in $) in Cabo Verde in 2010 to that in 2011?
Provide a short and direct response. 1.44. What is the ratio of the Expenses (in $) of Georgia in 2010 to that in 2011?
Your response must be concise. 1.41. What is the ratio of the Expenses (in $) of Nigeria in 2010 to that in 2011?
Your answer should be very brief. 0.76. What is the ratio of the Expenses (in $) in Oman in 2010 to that in 2011?
Make the answer very short. 0.73. What is the ratio of the Expenses (in $) of Cabo Verde in 2010 to that in 2012?
Give a very brief answer. 1.59. What is the ratio of the Expenses (in $) in Georgia in 2010 to that in 2012?
Keep it short and to the point. 1.11. What is the ratio of the Expenses (in $) of Nigeria in 2010 to that in 2012?
Your response must be concise. 0.73. What is the ratio of the Expenses (in $) of Oman in 2010 to that in 2012?
Your answer should be compact. 0.58. What is the ratio of the Expenses (in $) in Cabo Verde in 2011 to that in 2012?
Ensure brevity in your answer.  1.11. What is the ratio of the Expenses (in $) in Georgia in 2011 to that in 2012?
Give a very brief answer. 0.79. What is the ratio of the Expenses (in $) of Nigeria in 2011 to that in 2012?
Your response must be concise. 0.96. What is the ratio of the Expenses (in $) of Oman in 2011 to that in 2012?
Offer a terse response. 0.79. What is the difference between the highest and the second highest Expenses (in $) of Cabo Verde?
Make the answer very short. 1.45e+09. What is the difference between the highest and the second highest Expenses (in $) of Georgia?
Your answer should be very brief. 1.47e+08. What is the difference between the highest and the second highest Expenses (in $) of Nigeria?
Keep it short and to the point. 9.56e+1. What is the difference between the highest and the second highest Expenses (in $) in Oman?
Provide a succinct answer. 2.70e+09. What is the difference between the highest and the lowest Expenses (in $) of Cabo Verde?
Offer a very short reply. 4.31e+09. What is the difference between the highest and the lowest Expenses (in $) of Georgia?
Offer a terse response. 4.15e+08. What is the difference between the highest and the lowest Expenses (in $) of Nigeria?
Make the answer very short. 1.15e+12. What is the difference between the highest and the lowest Expenses (in $) of Oman?
Ensure brevity in your answer.  8.05e+09. 